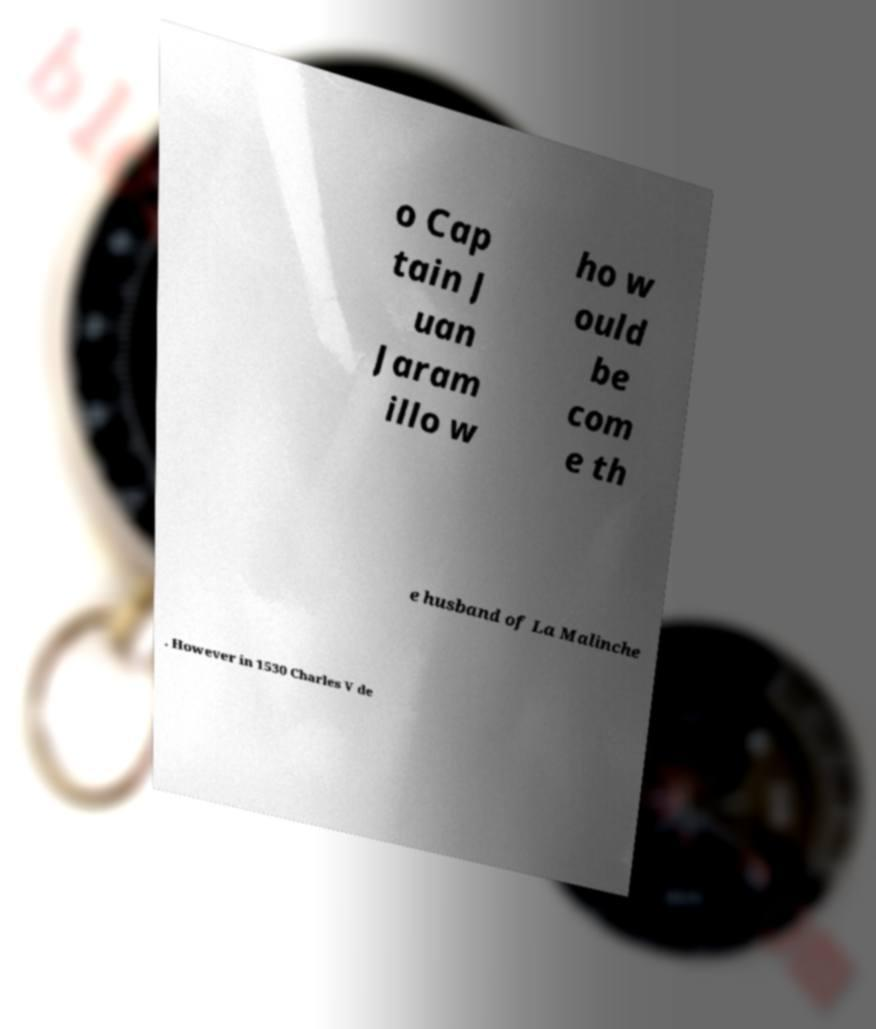Please identify and transcribe the text found in this image. o Cap tain J uan Jaram illo w ho w ould be com e th e husband of La Malinche . However in 1530 Charles V de 